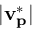Convert formula to latex. <formula><loc_0><loc_0><loc_500><loc_500>| v _ { p } ^ { * } |</formula> 